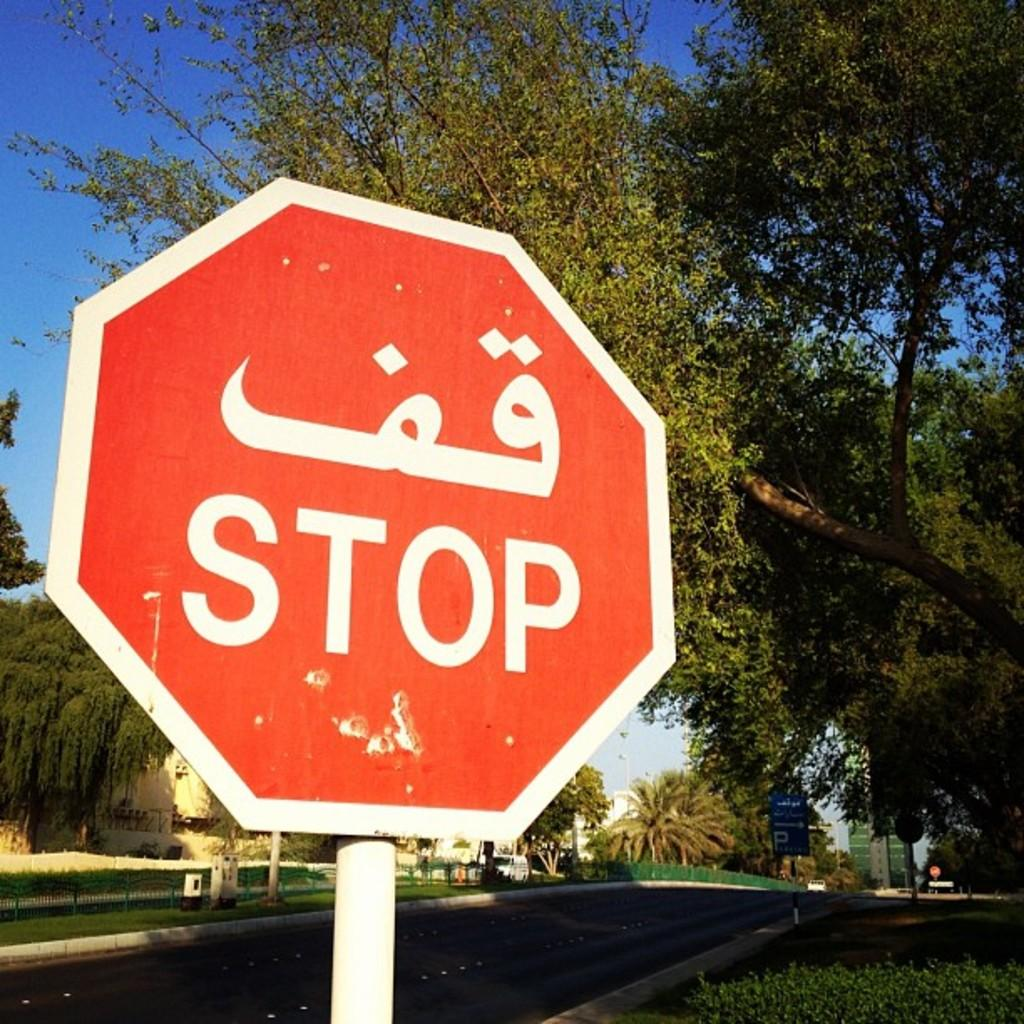<image>
Describe the image concisely. A red sign that says Stop is on the side of a street under a tree. 